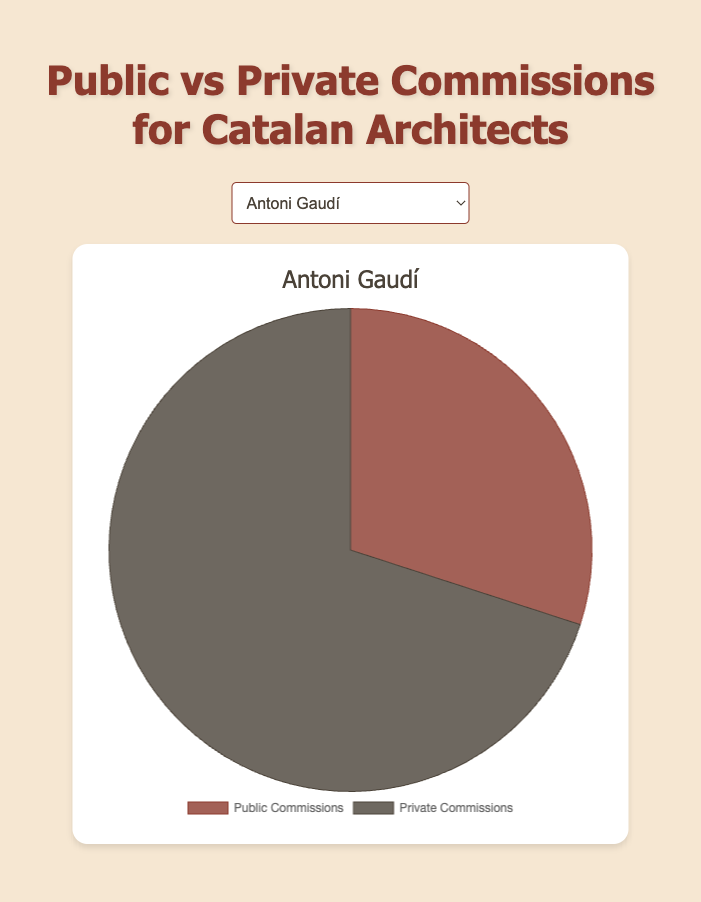Which architect has the highest number of public commissions? By looking at the pie chart for each architect, Antoni Gaudí has 15 public commissions, Lluís Domènech i Montaner has 18, Josep Puig i Cadafalch has 10, Rafael Masó i Valentí has 12, and Cèsar Martinell has 20. Therefore, Cèsar Martinell has the highest number of public commissions.
Answer: Cèsar Martinell Which architect has more private commissions than public commissions? By comparing the public and private commissions from the pie charts, Antoni Gaudí has 15 public and 35 private, Lluís Domènech i Montaner has 18 public and 22 private, Josep Puig i Cadafalch has 10 public and 25 private, and Rafael Masó i Valentí has 12 public and 20 private. All these architects have more private commissions than public.
Answer: Antoni Gaudí, Lluís Domènech i Montaner, Josep Puig i Cadafalch, and Rafael Masó i Valentí How many more private commissions does Josep Puig i Cadafalch have compared to his public commissions? Josep Puig i Cadafalch has 10 public commissions and 25 private commissions. The difference is 25 - 10 = 15.
Answer: 15 What is the ratio of public to private commissions for Antoni Gaudí in simplified form? Antoni Gaudí has 15 public commissions and 35 private commissions. The ratio is 15:35, which can be simplified by dividing both numbers by their greatest common divisor (5), resulting in a simplified ratio of 3:7.
Answer: 3:7 Which architect has the least number of private commissions? By looking at the pie chart data, Antoni Gaudí has 35 private commissions, Lluís Domènech i Montaner has 22, Josep Puig i Cadafalch has 25, Rafael Masó i Valentí has 20, and Cèsar Martinell has 15. Therefore, Cèsar Martinell has the least number of private commissions.
Answer: Cèsar Martinell What percent of Lluís Domènech i Montaner’s commissions are public? Lluís Domènech i Montaner has 18 public and 22 private commissions for a total of 40 commissions. The percentage of public commissions is (18/40) * 100 = 45%.
Answer: 45% Which architect has the most balanced ratio of public to private commissions? By comparing the pie chart data ratios of public to private commissions, Cèsar Martinell has the ratios as follows: Antoni Gaudí (15:35), Lluís Domènech i Montaner (18:22), Josep Puig i Cadafalch (10:25), Rafael Masó i Valentí (12:20), and Cèsar Martinell (20:15). The most balanced ratio close to 1:1 is Cèsar Martinell's 20:15.
Answer: Cèsar Martinell How many total commissions does Rafael Masó i Valentí have? Rafael Masó i Valentí has 12 public and 20 private commissions. The total is 12 + 20 = 32.
Answer: 32 If we sum all public commissions from all architects, what is the total? Summing up the public commissions: Antoni Gaudí (15), Lluís Domènech i Montaner (18), Josep Puig i Cadafalch (10), Rafael Masó i Valentí (12), and Cèsar Martinell (20). The total is 15 + 18 + 10 + 12 + 20 = 75.
Answer: 75 